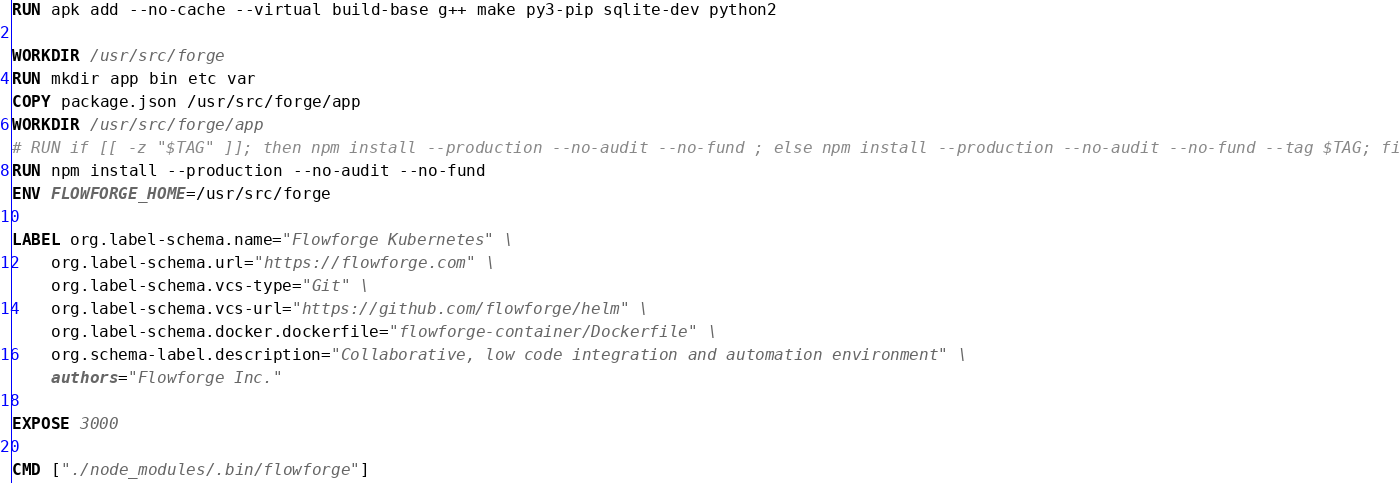<code> <loc_0><loc_0><loc_500><loc_500><_Dockerfile_>
RUN apk add --no-cache --virtual build-base g++ make py3-pip sqlite-dev python2

WORKDIR /usr/src/forge
RUN mkdir app bin etc var
COPY package.json /usr/src/forge/app
WORKDIR /usr/src/forge/app
# RUN if [[ -z "$TAG" ]]; then npm install --production --no-audit --no-fund ; else npm install --production --no-audit --no-fund --tag $TAG; fi
RUN npm install --production --no-audit --no-fund
ENV FLOWFORGE_HOME=/usr/src/forge

LABEL org.label-schema.name="Flowforge Kubernetes" \
    org.label-schema.url="https://flowforge.com" \
    org.label-schema.vcs-type="Git" \
    org.label-schema.vcs-url="https://github.com/flowforge/helm" \
    org.label-schema.docker.dockerfile="flowforge-container/Dockerfile" \
    org.schema-label.description="Collaborative, low code integration and automation environment" \
    authors="Flowforge Inc."

EXPOSE 3000

CMD ["./node_modules/.bin/flowforge"]</code> 